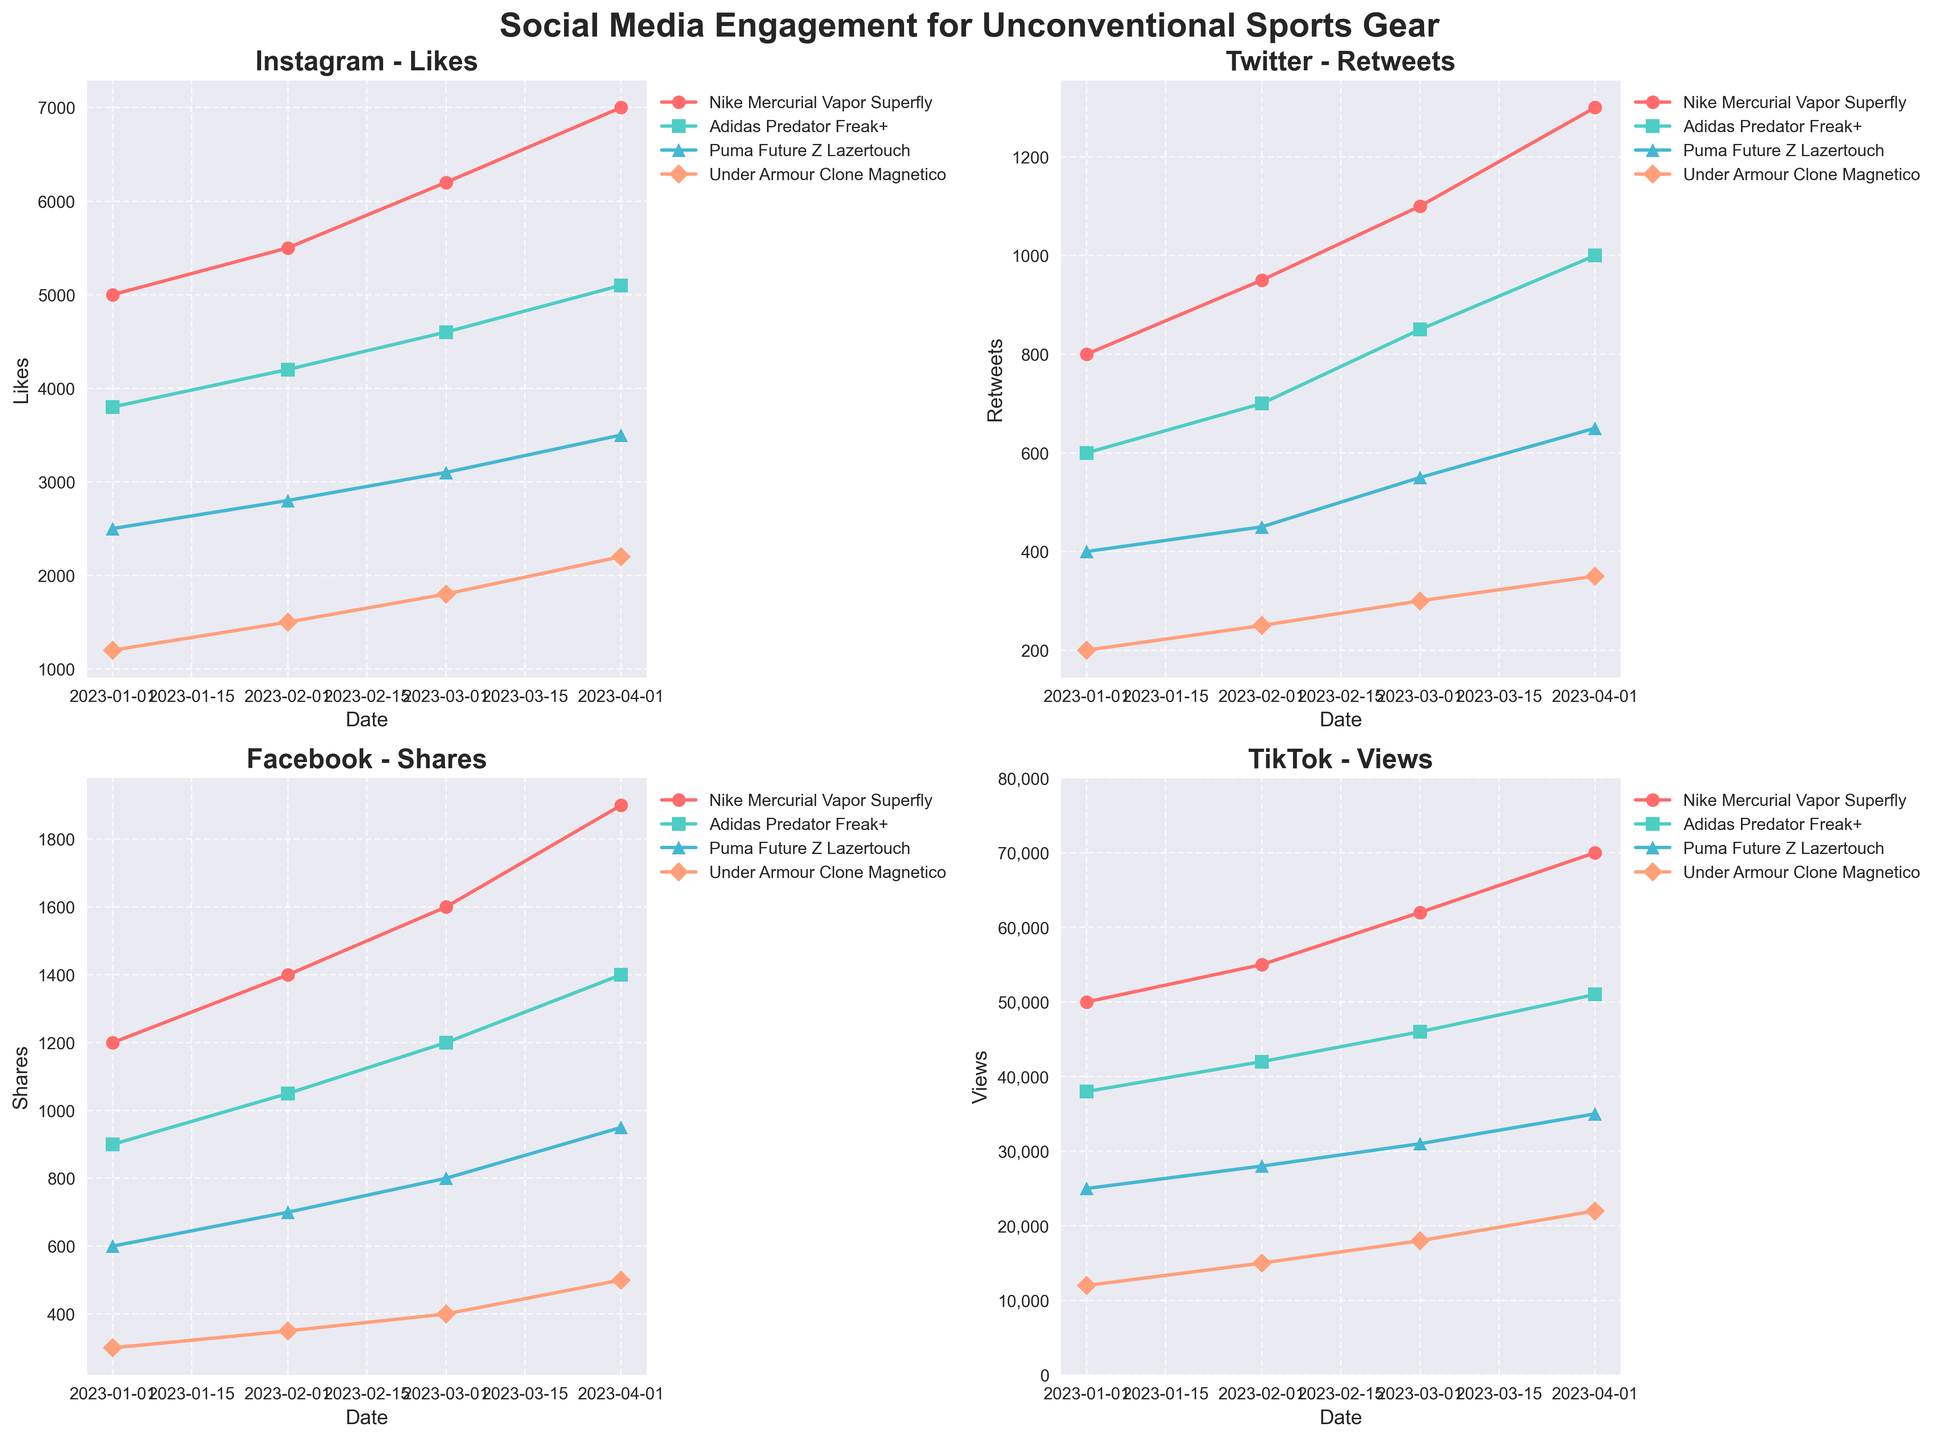How many total data points are plotted in the figure? There are four platforms, each with four products, and engagement metrics are collected over four months. This gives 4 platforms * 4 products * 4 data points = 64 data points.
Answer: 64 Which platform shows the largest numerical range in engagement metrics for Nike Mercurial Vapor Superfly? TikTok has the largest range for Nike Mercurial Vapor Superfly, from 50,000 (January) to 70,000 (April), a range of 20,000.
Answer: TikTok For Instagram posts, which product received the most likes in April 2023? Checking the data points on the Instagram subplot for April 2023, Nike Mercurial Vapor Superfly has the highest engagement metric at 7,000 likes.
Answer: Nike Mercurial Vapor Superfly What is the average number of retweets for Adidas Predator Freak+ posts on Twitter over the given months? The retweets for Adidas Predator Freak+ are 600, 700, 850, and 1000 across four months. The average is (600 + 700 + 850 + 1000) / 4 = 787.5.
Answer: 787.5 Between Puma Future Z Lazertouch and Under Armour Clone Magnetico, which product shows a higher engagement trend on Facebook over time? Both products can be observed on the Facebook subplot. By checking the growth rate over the months, it's seen that Puma Future Z Lazertouch grows from 600 to 950 (a net increase of 350), while Under Armour Clone Magnetico grows from 300 to 500 (a net increase of 200). Puma Future Z Lazertouch shows a higher increase.
Answer: Puma Future Z Lazertouch Which product has the smallest difference in engagement metrics on TikTok from January 2023 to April 2023? On the TikTok subplot, calculate the difference for each product: Nike Mercurial Vapor Superfly (20000), Adidas Predator Freak+ (13000), Puma Future Z Lazertouch (10000), Under Armour Clone Magnetico (10000). The smallest differences are for Puma Future Z Lazertouch and Under Armour Clone Magnetico, both at 10000.
Answer: Puma Future Z Lazertouch, Under Armour Clone Magnetico Which month saw the highest engagement increase for all products on all platforms? Observing and summing the differences in engagement metrics for each month across all four platforms and products: all product engagements increased the most between February and March for each platform.
Answer: March What is the general trend of engagement for Under Armour Clone Magnetico across all platforms? By examining the engagement lines for Under Armour Clone Magnetico on all subplots, it is clear that engagement metrics consistently increase over the months for all platforms.
Answer: Increasing 